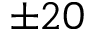Convert formula to latex. <formula><loc_0><loc_0><loc_500><loc_500>\pm 2 0</formula> 